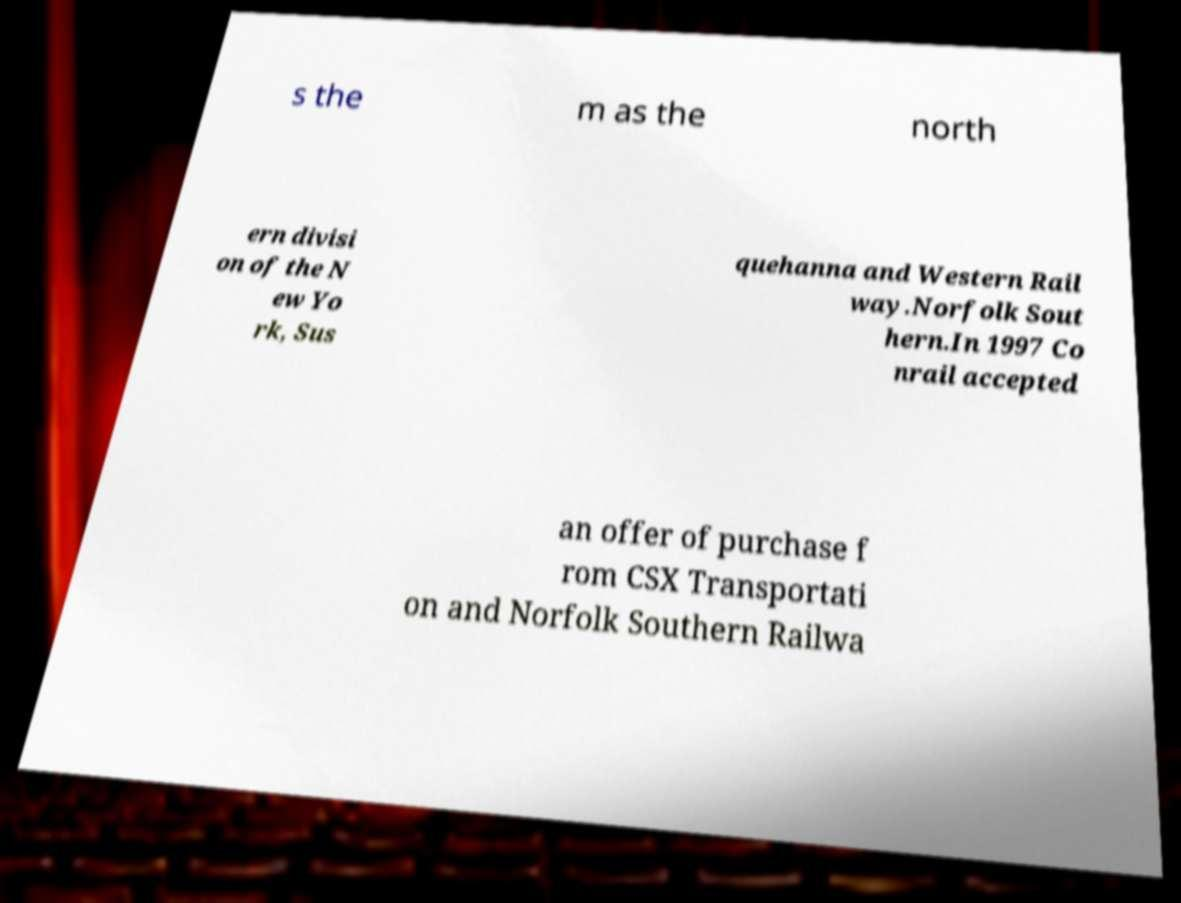Could you assist in decoding the text presented in this image and type it out clearly? s the m as the north ern divisi on of the N ew Yo rk, Sus quehanna and Western Rail way.Norfolk Sout hern.In 1997 Co nrail accepted an offer of purchase f rom CSX Transportati on and Norfolk Southern Railwa 